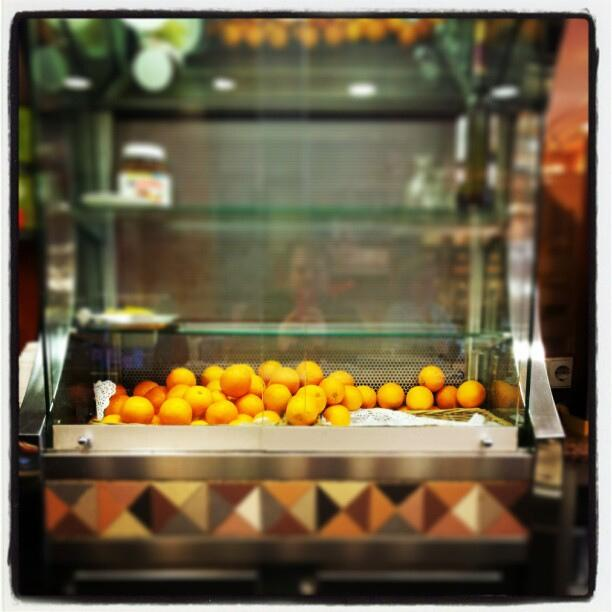What vitamin does this fruit contain the most? Please explain your reasoning. vitamin c. Oranges are a citrus fruit so they contain vitamin c. 